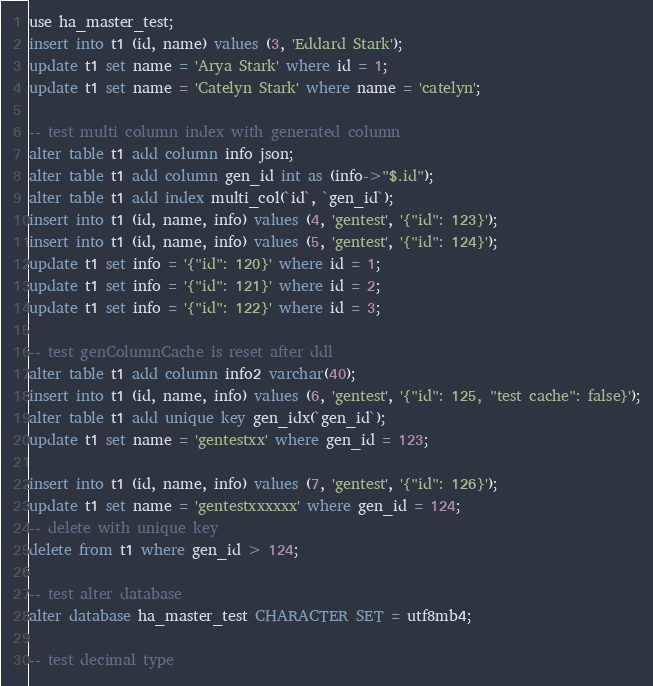Convert code to text. <code><loc_0><loc_0><loc_500><loc_500><_SQL_>use ha_master_test;
insert into t1 (id, name) values (3, 'Eddard Stark');
update t1 set name = 'Arya Stark' where id = 1;
update t1 set name = 'Catelyn Stark' where name = 'catelyn';

-- test multi column index with generated column
alter table t1 add column info json;
alter table t1 add column gen_id int as (info->"$.id");
alter table t1 add index multi_col(`id`, `gen_id`);
insert into t1 (id, name, info) values (4, 'gentest', '{"id": 123}');
insert into t1 (id, name, info) values (5, 'gentest', '{"id": 124}');
update t1 set info = '{"id": 120}' where id = 1;
update t1 set info = '{"id": 121}' where id = 2;
update t1 set info = '{"id": 122}' where id = 3;

-- test genColumnCache is reset after ddl
alter table t1 add column info2 varchar(40);
insert into t1 (id, name, info) values (6, 'gentest', '{"id": 125, "test cache": false}');
alter table t1 add unique key gen_idx(`gen_id`);
update t1 set name = 'gentestxx' where gen_id = 123;

insert into t1 (id, name, info) values (7, 'gentest', '{"id": 126}');
update t1 set name = 'gentestxxxxxx' where gen_id = 124;
-- delete with unique key
delete from t1 where gen_id > 124;

-- test alter database
alter database ha_master_test CHARACTER SET = utf8mb4;

-- test decimal type</code> 